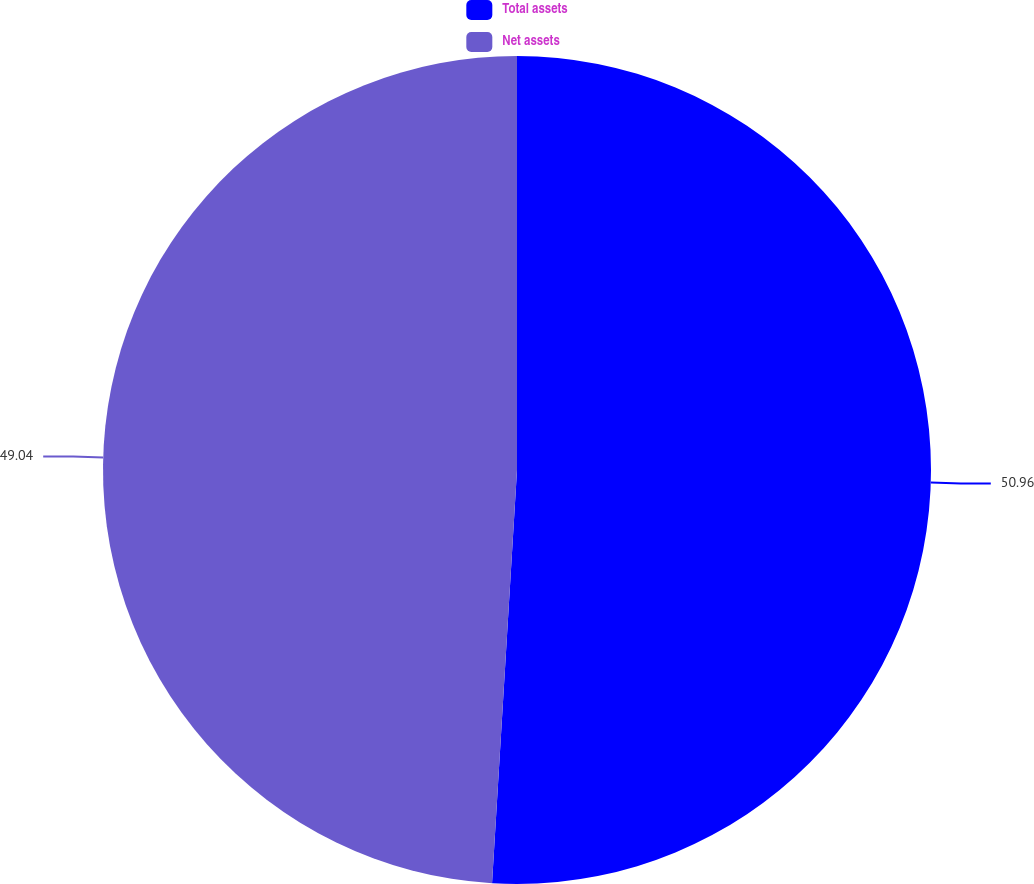<chart> <loc_0><loc_0><loc_500><loc_500><pie_chart><fcel>Total assets<fcel>Net assets<nl><fcel>50.96%<fcel>49.04%<nl></chart> 